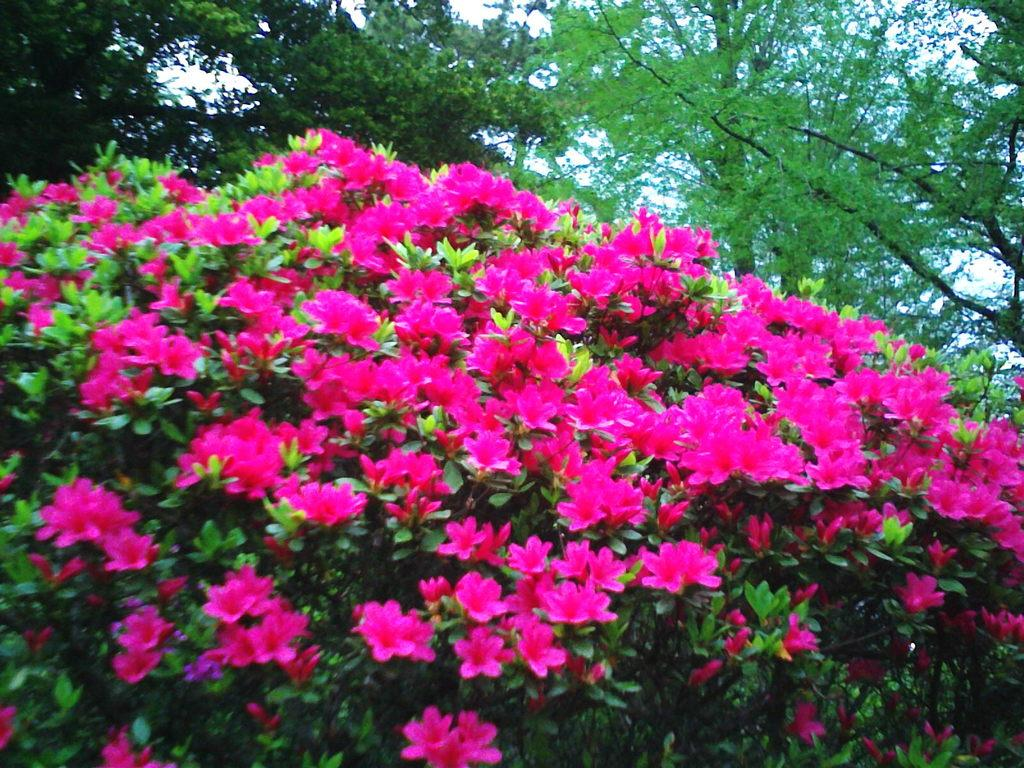What type of plants can be seen in the image? There are plants with pink flowers in the image. What color are the leaves of the plants? The plants have green leaves. What other vegetation is visible in the image? There are tall trees visible in the image. What is the color of the tall trees? The tall trees are light green in color. How many rays are visible in the image? There are no rays visible in the image; it features plants and trees. Can you see any snakes slithering among the plants in the image? There are no snakes present in the image. 